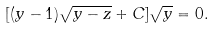<formula> <loc_0><loc_0><loc_500><loc_500>[ ( y - 1 ) \sqrt { y - z } + C ] \sqrt { y } = 0 .</formula> 